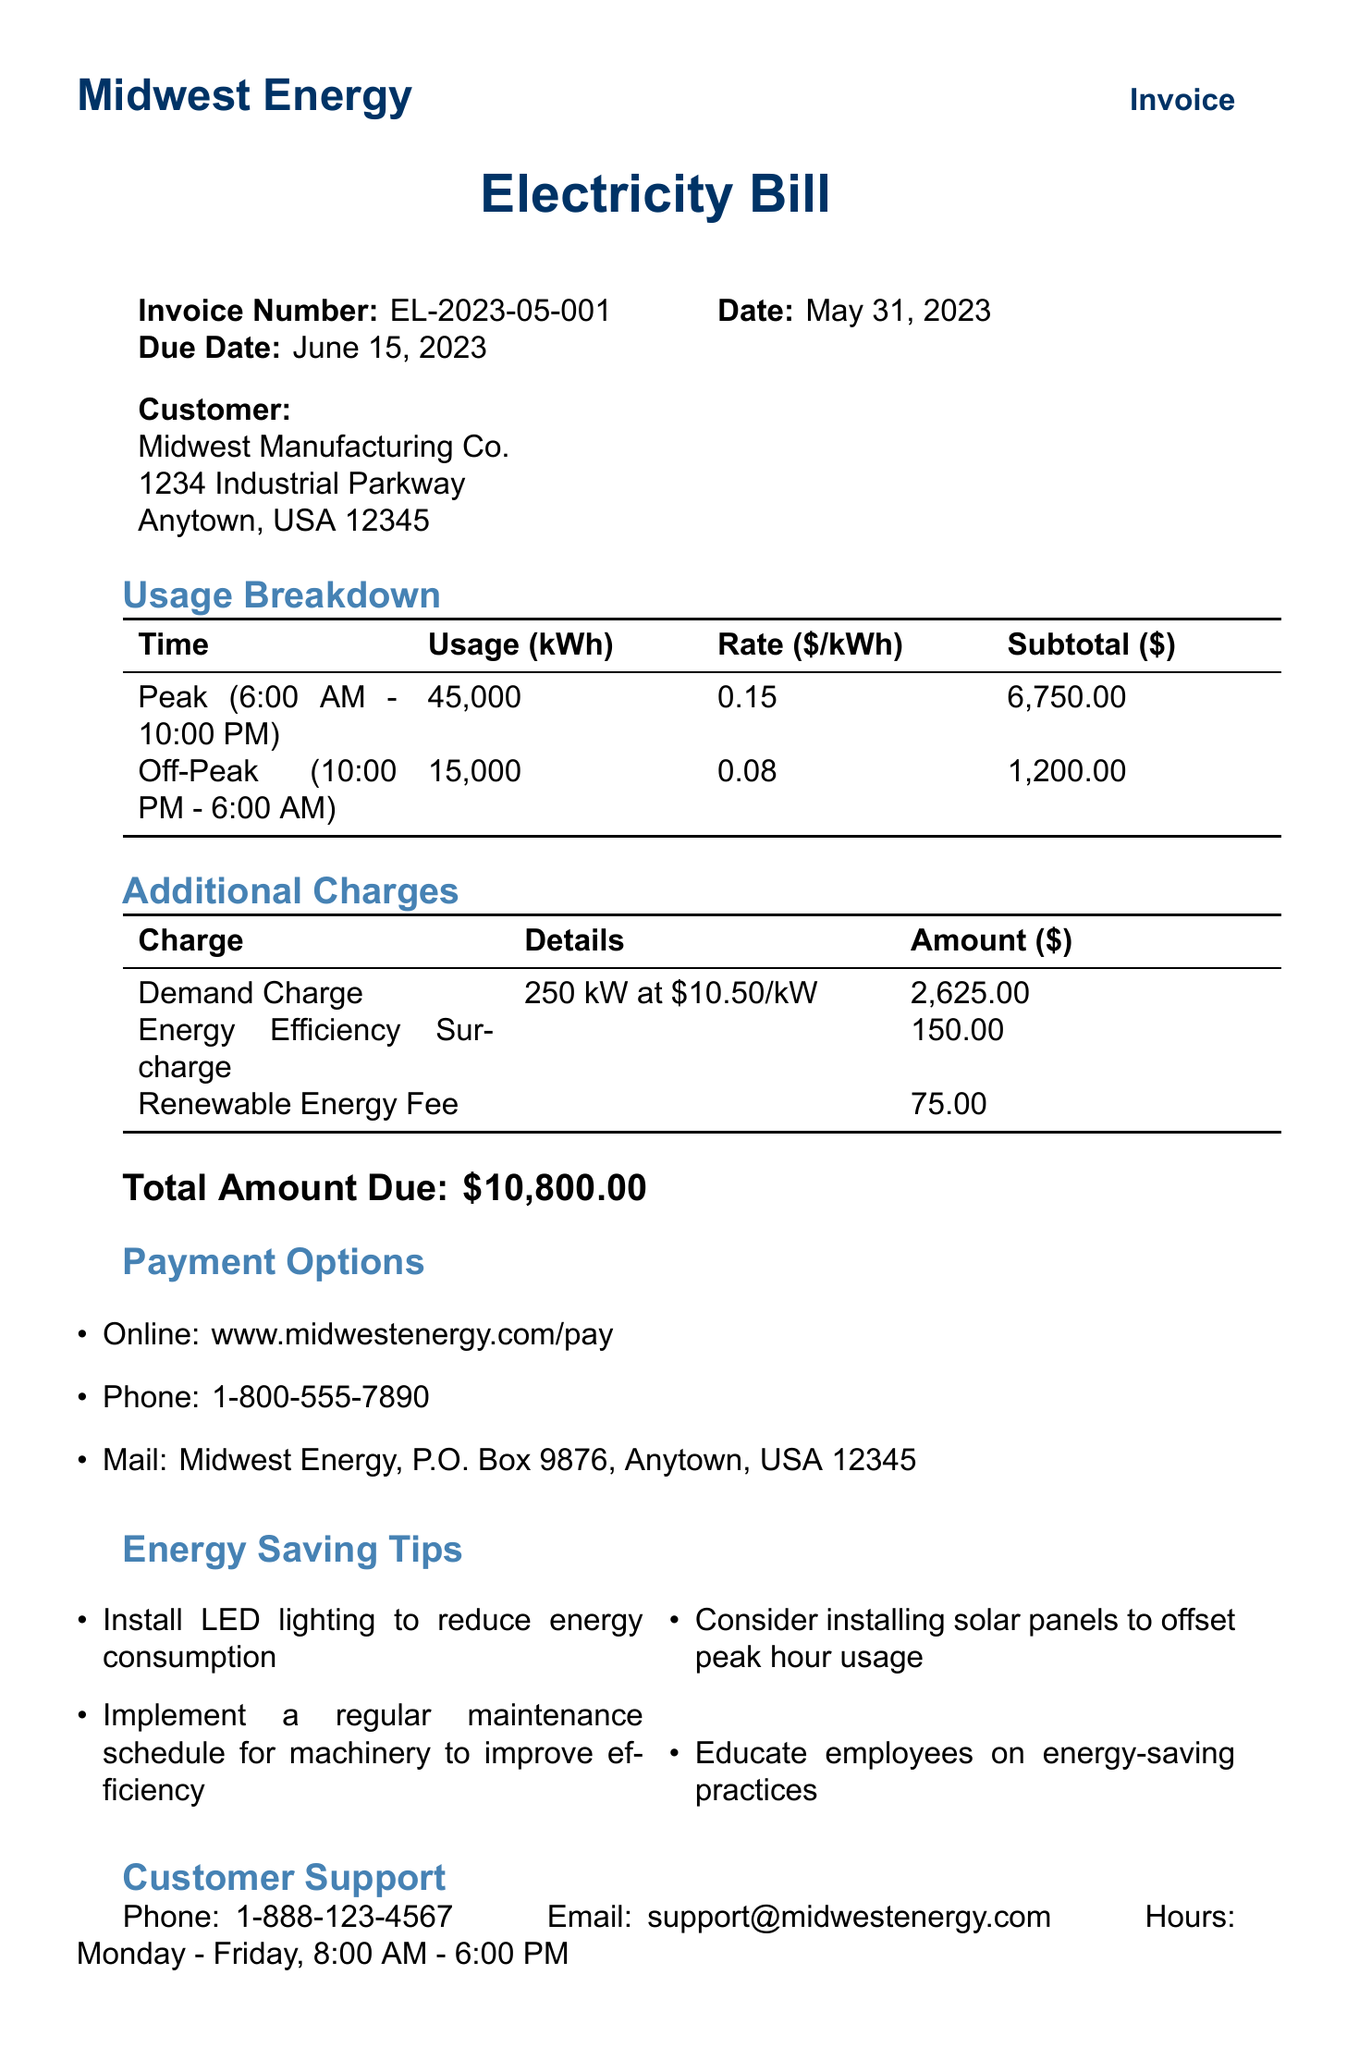What is the invoice number? The invoice number is a unique identifier for this bill, which is provided in the document.
Answer: EL-2023-05-001 What is the total amount due? The total amount due is stated at the end of the invoice, summarizing all charges.
Answer: $10,800.00 How much is the renewable energy fee? The renewable energy fee is an additional charge listed in the invoice under additional charges.
Answer: $75.00 What is the usage during peak hours? The total usage during peak hours is reported in the usage breakdown section of the document.
Answer: 45,000 kWh What are the operating hours for customer support? The operating hours for customer support are specified clearly in the customer support section.
Answer: Monday - Friday, 8:00 AM - 6:00 PM How much is the energy efficiency surcharge? The energy efficiency surcharge amount is detailed in the additional charges section of the invoice.
Answer: $150.00 What is the peak demand in kW? The peak demand is noted as part of the additional charges under demand charge.
Answer: 250 kW What is the time range for off-peak hours? The time range for off-peak hours is provided in the usage breakdown section of the document.
Answer: 10:00 PM - 6:00 AM What type of educational resource is offered for free? The document lists an online course that is free for customers as an educational resource.
Answer: Understanding Your Factory's Energy Usage 